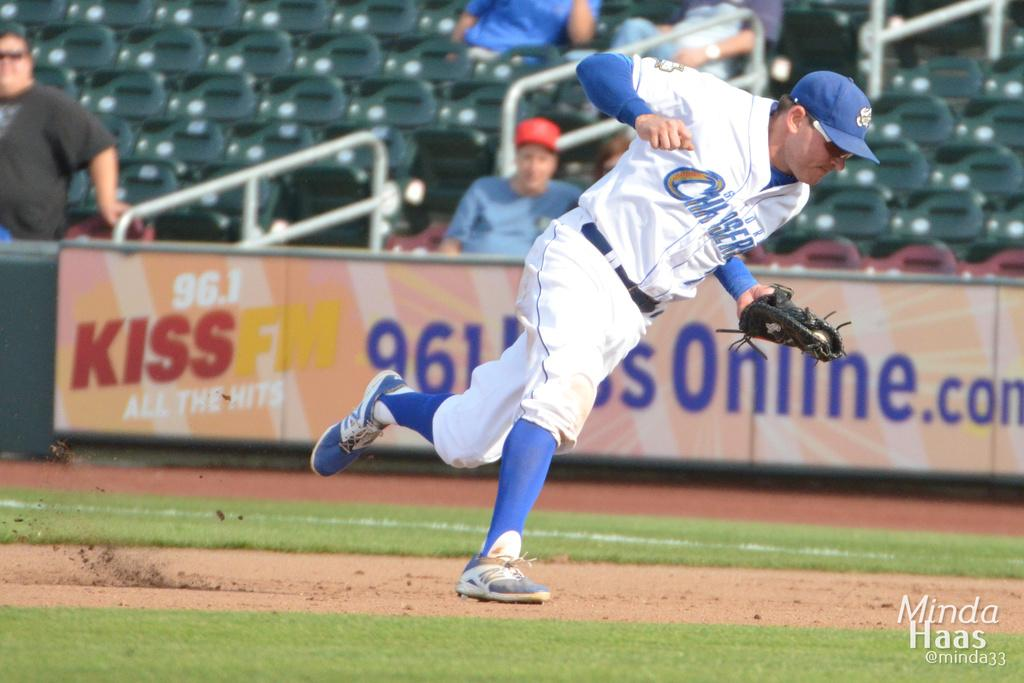<image>
Create a compact narrative representing the image presented. A baseball player in a white and blue storm chasers uniform. 